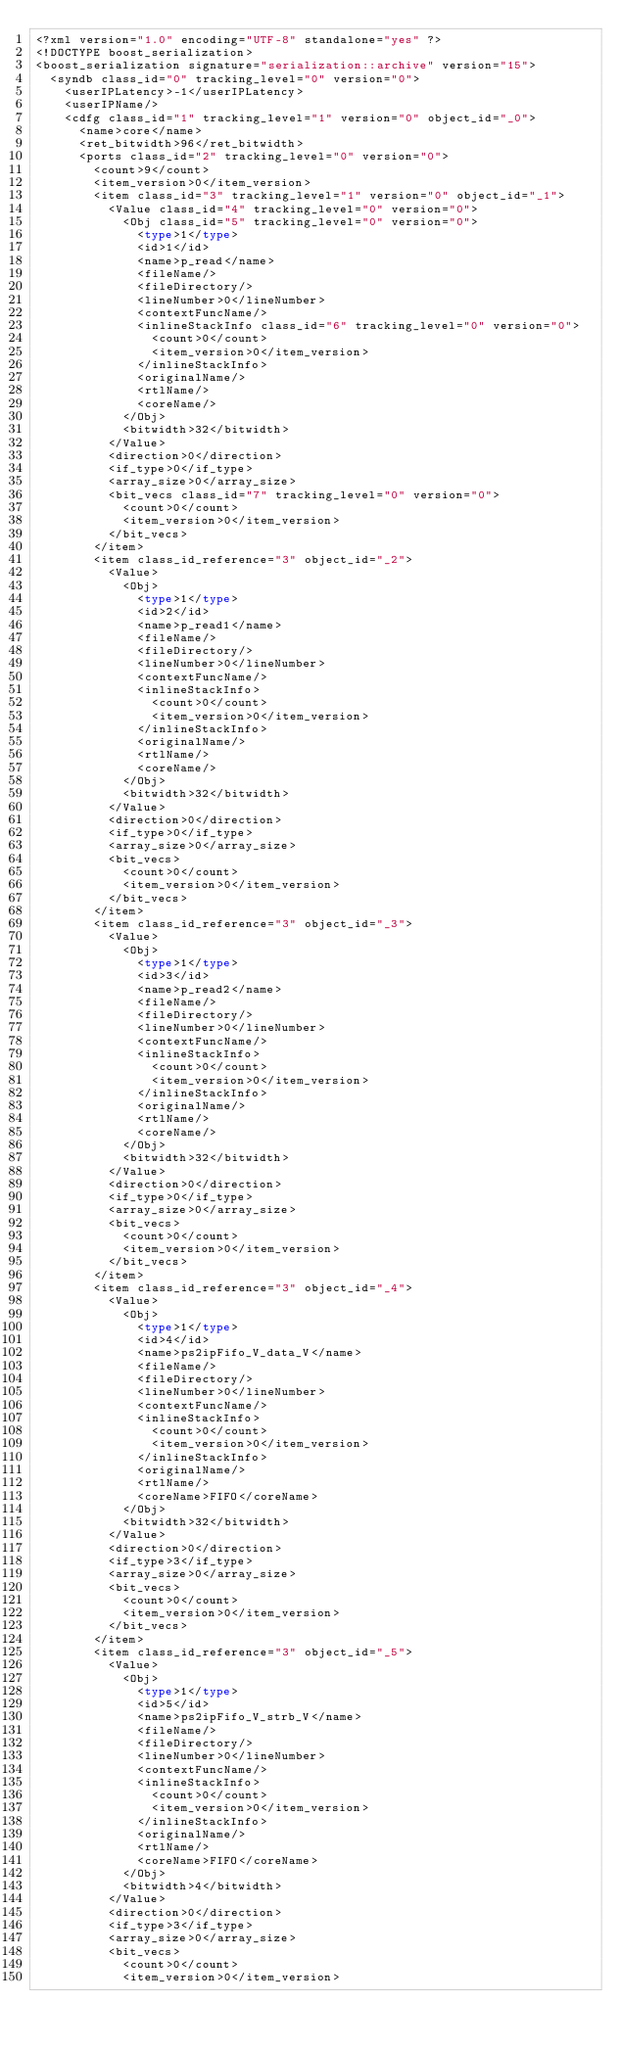<code> <loc_0><loc_0><loc_500><loc_500><_Ada_><?xml version="1.0" encoding="UTF-8" standalone="yes" ?>
<!DOCTYPE boost_serialization>
<boost_serialization signature="serialization::archive" version="15">
  <syndb class_id="0" tracking_level="0" version="0">
    <userIPLatency>-1</userIPLatency>
    <userIPName/>
    <cdfg class_id="1" tracking_level="1" version="0" object_id="_0">
      <name>core</name>
      <ret_bitwidth>96</ret_bitwidth>
      <ports class_id="2" tracking_level="0" version="0">
        <count>9</count>
        <item_version>0</item_version>
        <item class_id="3" tracking_level="1" version="0" object_id="_1">
          <Value class_id="4" tracking_level="0" version="0">
            <Obj class_id="5" tracking_level="0" version="0">
              <type>1</type>
              <id>1</id>
              <name>p_read</name>
              <fileName/>
              <fileDirectory/>
              <lineNumber>0</lineNumber>
              <contextFuncName/>
              <inlineStackInfo class_id="6" tracking_level="0" version="0">
                <count>0</count>
                <item_version>0</item_version>
              </inlineStackInfo>
              <originalName/>
              <rtlName/>
              <coreName/>
            </Obj>
            <bitwidth>32</bitwidth>
          </Value>
          <direction>0</direction>
          <if_type>0</if_type>
          <array_size>0</array_size>
          <bit_vecs class_id="7" tracking_level="0" version="0">
            <count>0</count>
            <item_version>0</item_version>
          </bit_vecs>
        </item>
        <item class_id_reference="3" object_id="_2">
          <Value>
            <Obj>
              <type>1</type>
              <id>2</id>
              <name>p_read1</name>
              <fileName/>
              <fileDirectory/>
              <lineNumber>0</lineNumber>
              <contextFuncName/>
              <inlineStackInfo>
                <count>0</count>
                <item_version>0</item_version>
              </inlineStackInfo>
              <originalName/>
              <rtlName/>
              <coreName/>
            </Obj>
            <bitwidth>32</bitwidth>
          </Value>
          <direction>0</direction>
          <if_type>0</if_type>
          <array_size>0</array_size>
          <bit_vecs>
            <count>0</count>
            <item_version>0</item_version>
          </bit_vecs>
        </item>
        <item class_id_reference="3" object_id="_3">
          <Value>
            <Obj>
              <type>1</type>
              <id>3</id>
              <name>p_read2</name>
              <fileName/>
              <fileDirectory/>
              <lineNumber>0</lineNumber>
              <contextFuncName/>
              <inlineStackInfo>
                <count>0</count>
                <item_version>0</item_version>
              </inlineStackInfo>
              <originalName/>
              <rtlName/>
              <coreName/>
            </Obj>
            <bitwidth>32</bitwidth>
          </Value>
          <direction>0</direction>
          <if_type>0</if_type>
          <array_size>0</array_size>
          <bit_vecs>
            <count>0</count>
            <item_version>0</item_version>
          </bit_vecs>
        </item>
        <item class_id_reference="3" object_id="_4">
          <Value>
            <Obj>
              <type>1</type>
              <id>4</id>
              <name>ps2ipFifo_V_data_V</name>
              <fileName/>
              <fileDirectory/>
              <lineNumber>0</lineNumber>
              <contextFuncName/>
              <inlineStackInfo>
                <count>0</count>
                <item_version>0</item_version>
              </inlineStackInfo>
              <originalName/>
              <rtlName/>
              <coreName>FIFO</coreName>
            </Obj>
            <bitwidth>32</bitwidth>
          </Value>
          <direction>0</direction>
          <if_type>3</if_type>
          <array_size>0</array_size>
          <bit_vecs>
            <count>0</count>
            <item_version>0</item_version>
          </bit_vecs>
        </item>
        <item class_id_reference="3" object_id="_5">
          <Value>
            <Obj>
              <type>1</type>
              <id>5</id>
              <name>ps2ipFifo_V_strb_V</name>
              <fileName/>
              <fileDirectory/>
              <lineNumber>0</lineNumber>
              <contextFuncName/>
              <inlineStackInfo>
                <count>0</count>
                <item_version>0</item_version>
              </inlineStackInfo>
              <originalName/>
              <rtlName/>
              <coreName>FIFO</coreName>
            </Obj>
            <bitwidth>4</bitwidth>
          </Value>
          <direction>0</direction>
          <if_type>3</if_type>
          <array_size>0</array_size>
          <bit_vecs>
            <count>0</count>
            <item_version>0</item_version></code> 